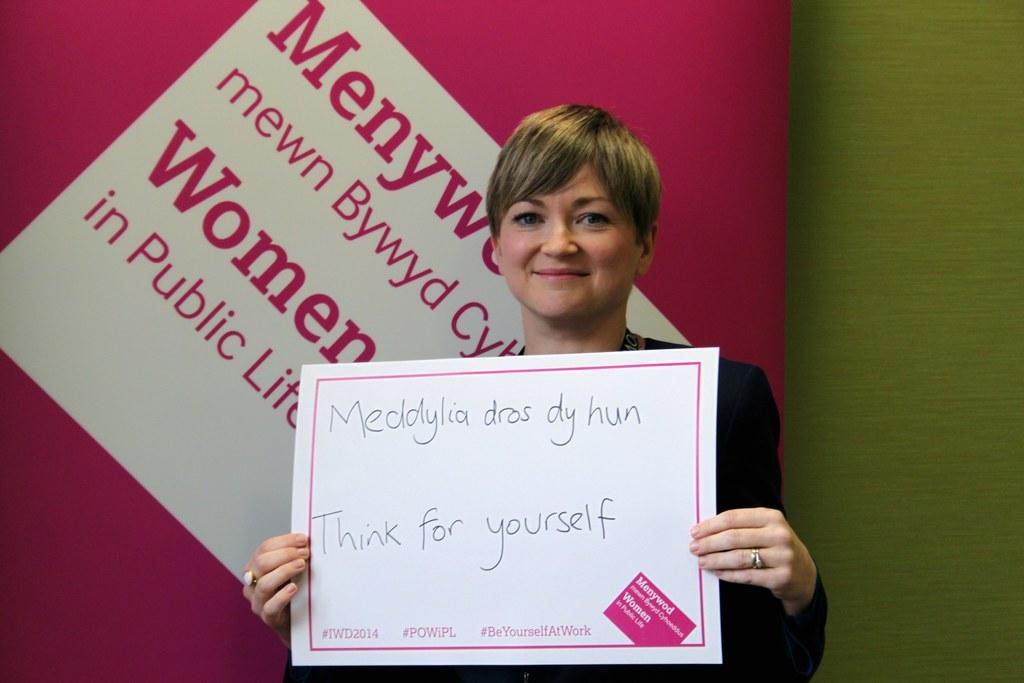Who is the main subject in the image? There is a woman in the image. What is the woman holding in her hand? The woman is holding a placard in her hand. What is the woman's facial expression in the image? The woman is smiling in the image. What can be seen on the wall behind the woman? There is text on a wall behind the woman. How does the woman's hair react to the shock in the image? There is no shock present in the image, and therefore no reaction can be observed in the woman's hair. 